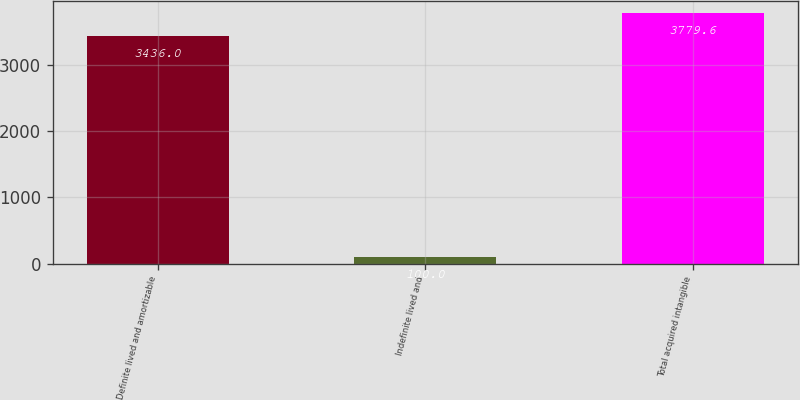Convert chart. <chart><loc_0><loc_0><loc_500><loc_500><bar_chart><fcel>Definite lived and amortizable<fcel>Indefinite lived and<fcel>Total acquired intangible<nl><fcel>3436<fcel>100<fcel>3779.6<nl></chart> 